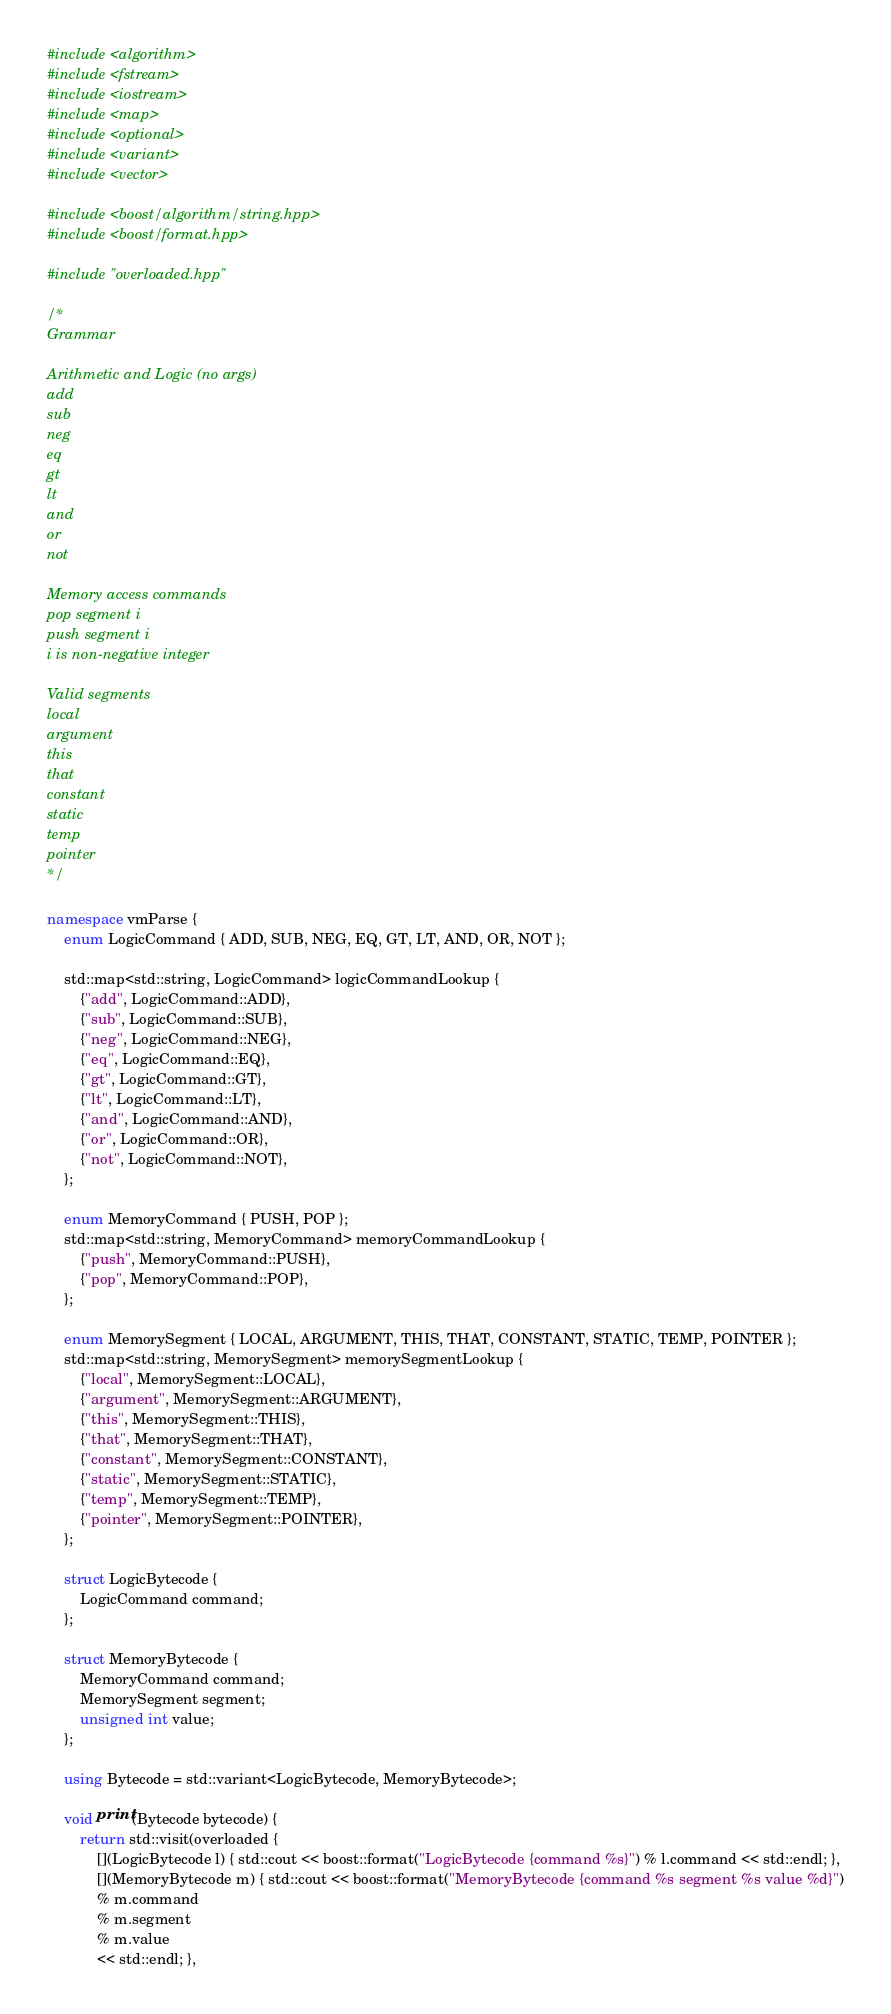Convert code to text. <code><loc_0><loc_0><loc_500><loc_500><_C++_>#include <algorithm>
#include <fstream>
#include <iostream>
#include <map>
#include <optional>
#include <variant>
#include <vector>

#include <boost/algorithm/string.hpp>
#include <boost/format.hpp>

#include "overloaded.hpp"

/* 
Grammar

Arithmetic and Logic (no args)
add
sub
neg
eq
gt
lt
and
or
not

Memory access commands
pop segment i
push segment i
i is non-negative integer

Valid segments
local
argument
this
that
constant
static
temp
pointer
*/

namespace vmParse {
    enum LogicCommand { ADD, SUB, NEG, EQ, GT, LT, AND, OR, NOT };

    std::map<std::string, LogicCommand> logicCommandLookup {
        {"add", LogicCommand::ADD},
        {"sub", LogicCommand::SUB},
        {"neg", LogicCommand::NEG},
        {"eq", LogicCommand::EQ},
        {"gt", LogicCommand::GT},
        {"lt", LogicCommand::LT},
        {"and", LogicCommand::AND},
        {"or", LogicCommand::OR},
        {"not", LogicCommand::NOT},
    };

    enum MemoryCommand { PUSH, POP };
    std::map<std::string, MemoryCommand> memoryCommandLookup {
        {"push", MemoryCommand::PUSH},
        {"pop", MemoryCommand::POP},
    };

    enum MemorySegment { LOCAL, ARGUMENT, THIS, THAT, CONSTANT, STATIC, TEMP, POINTER };
    std::map<std::string, MemorySegment> memorySegmentLookup {
        {"local", MemorySegment::LOCAL},
        {"argument", MemorySegment::ARGUMENT},
        {"this", MemorySegment::THIS},
        {"that", MemorySegment::THAT},
        {"constant", MemorySegment::CONSTANT},
        {"static", MemorySegment::STATIC},
        {"temp", MemorySegment::TEMP},
        {"pointer", MemorySegment::POINTER},  
    };

    struct LogicBytecode {
        LogicCommand command;
    };

    struct MemoryBytecode {
        MemoryCommand command;
        MemorySegment segment;
        unsigned int value;
    };

    using Bytecode = std::variant<LogicBytecode, MemoryBytecode>;    
        
    void print(Bytecode bytecode) {
        return std::visit(overloaded {
            [](LogicBytecode l) { std::cout << boost::format("LogicBytecode {command %s}") % l.command << std::endl; },
            [](MemoryBytecode m) { std::cout << boost::format("MemoryBytecode {command %s segment %s value %d}")
            % m.command
            % m.segment
            % m.value
            << std::endl; },</code> 